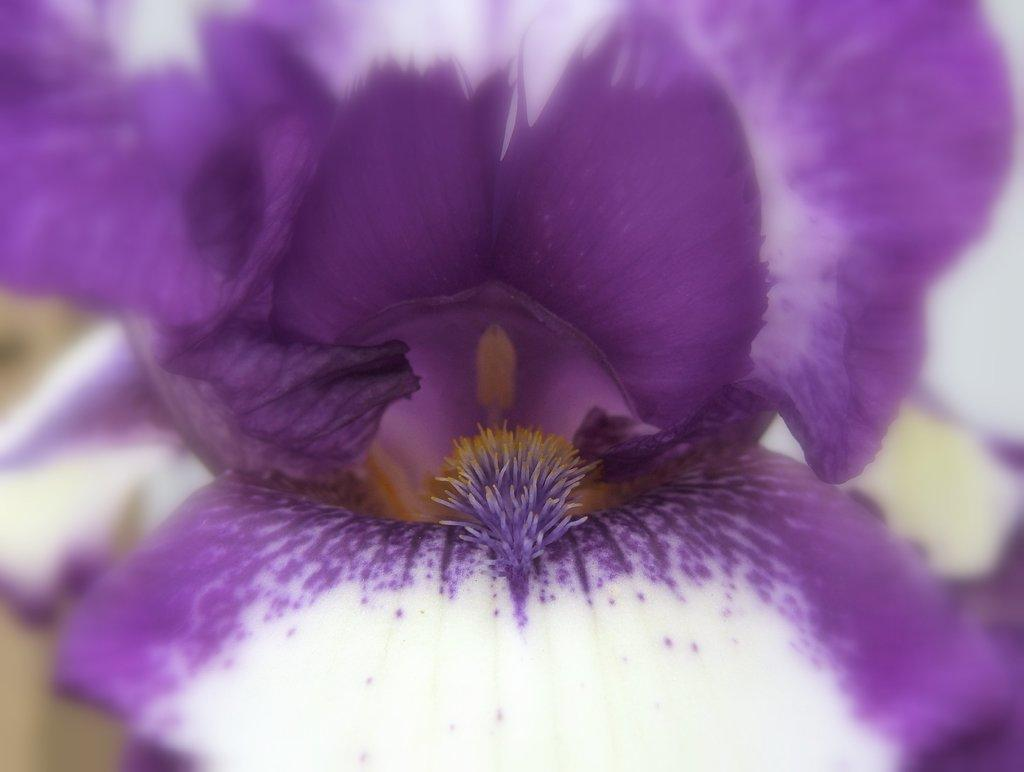What is the main subject of the image? The main subject of the image is a flower. Can you describe the colors of the flower? The flower has white and purple colors. Reasoning: Let's think step by identifying the main subject and its characteristics based on the provided facts. We start by mentioning the flower as the main subject and then describe its colors. We avoid any assumptions or speculations about the image and focus on the given facts. Absurd Question/Answer: What type of religious symbol can be seen in the image? There is no religious symbol present in the image; it features a flower with white and purple colors. Can you describe the type of tree in the image? There is no tree present in the image; it only contains a flower. 